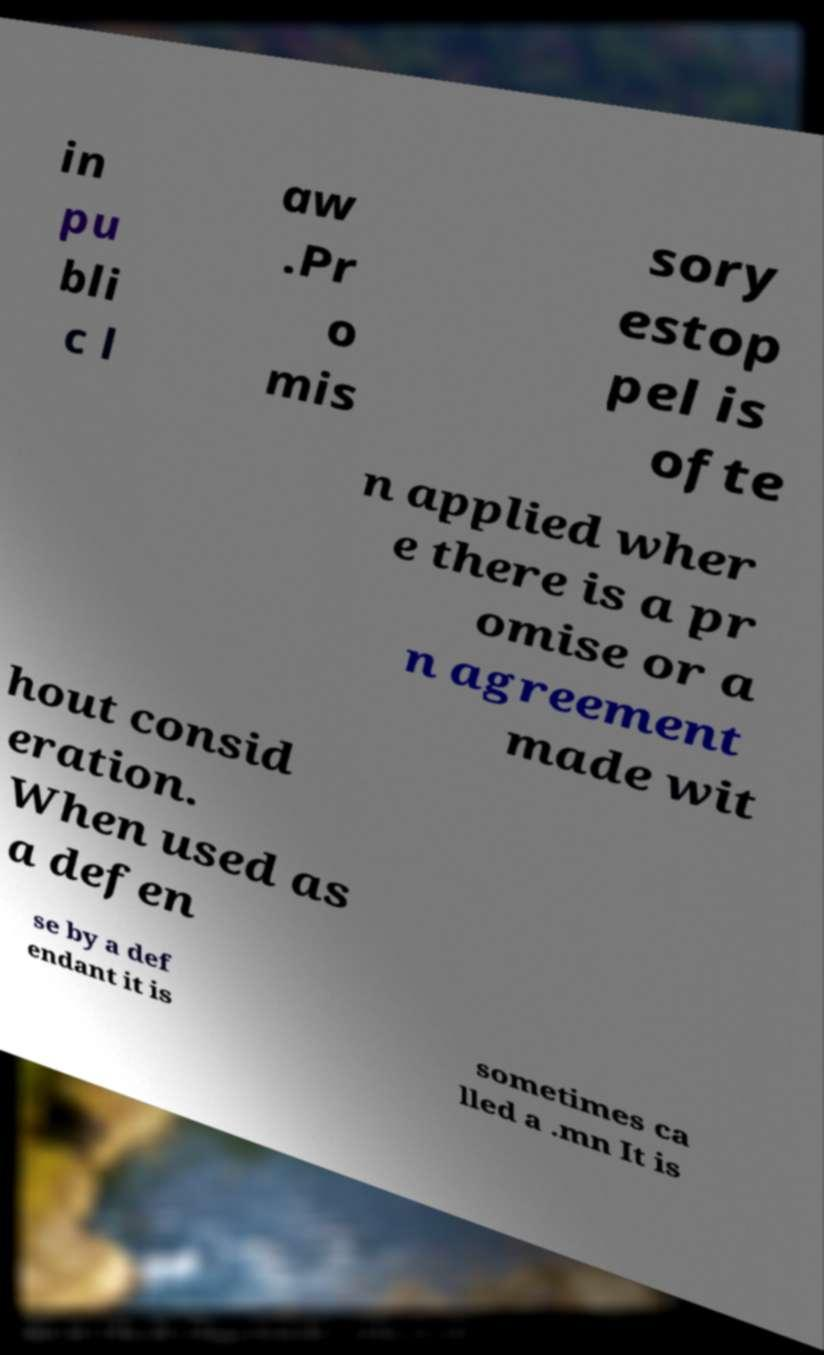Could you assist in decoding the text presented in this image and type it out clearly? in pu bli c l aw .Pr o mis sory estop pel is ofte n applied wher e there is a pr omise or a n agreement made wit hout consid eration. When used as a defen se by a def endant it is sometimes ca lled a .mn It is 